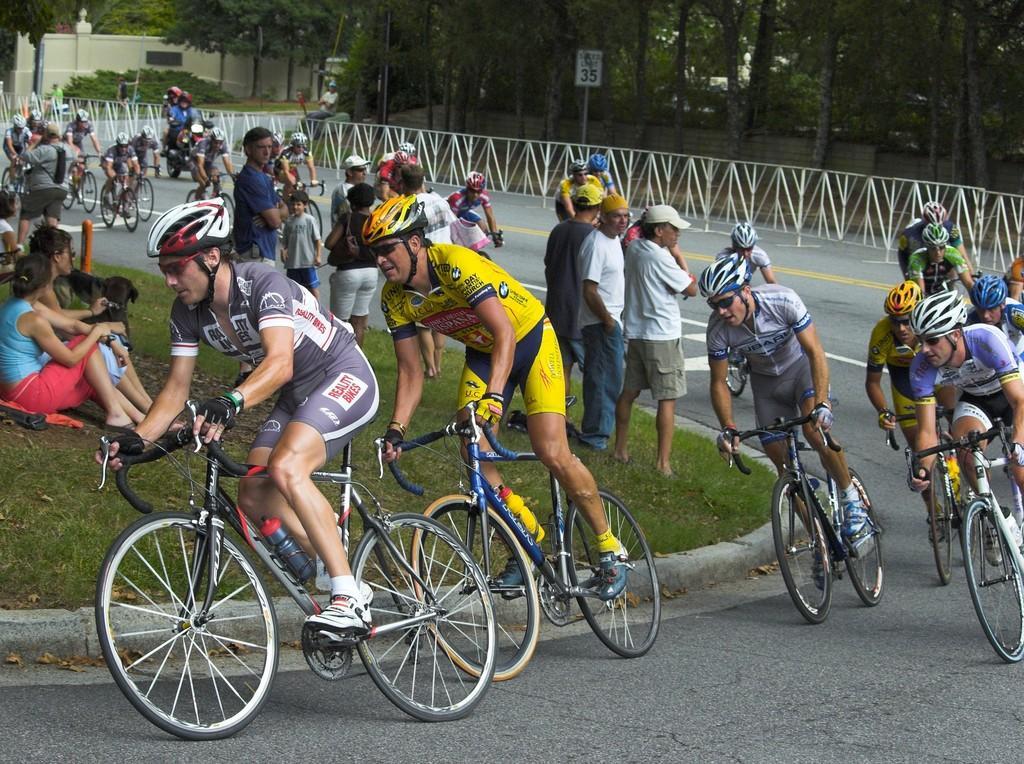Can you describe this image briefly? Here we can see a group of people who are riding a bicycle on a road. Here we can see a few people standing and sitting and watching these people. 